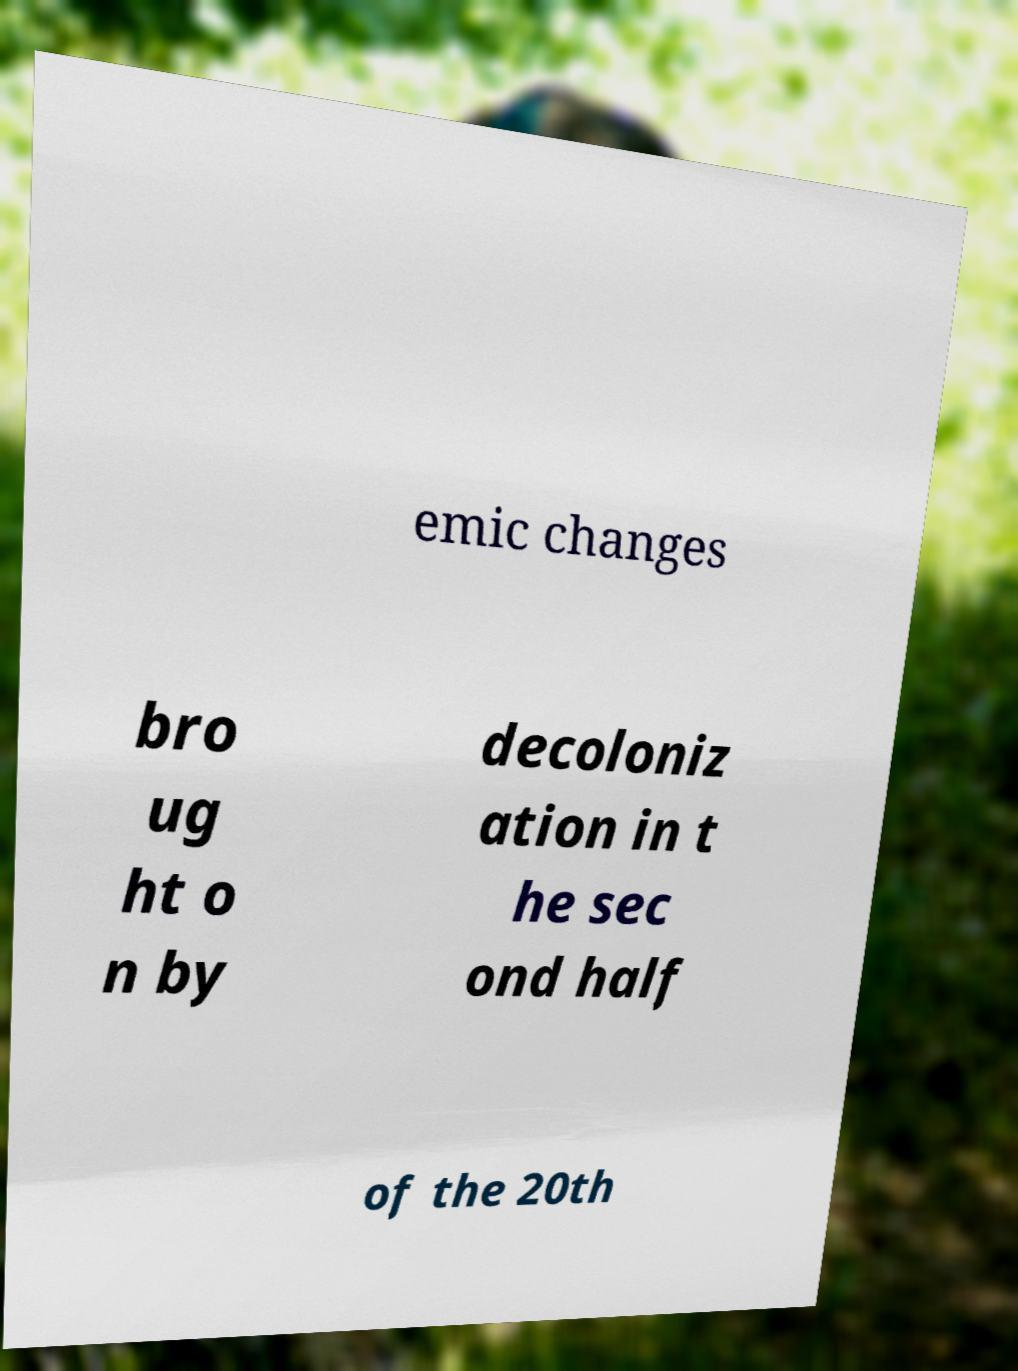Can you accurately transcribe the text from the provided image for me? emic changes bro ug ht o n by decoloniz ation in t he sec ond half of the 20th 